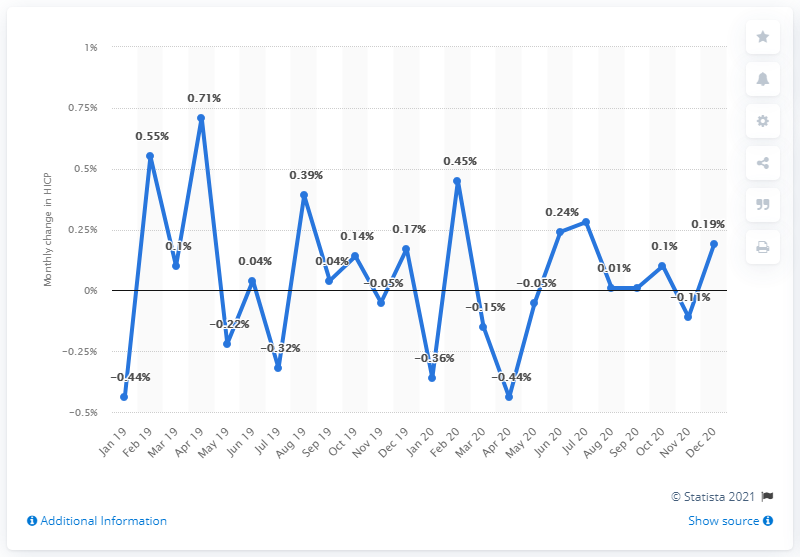List a handful of essential elements in this visual. As of December 2020, the HICP inflation rate was 0.19%. 